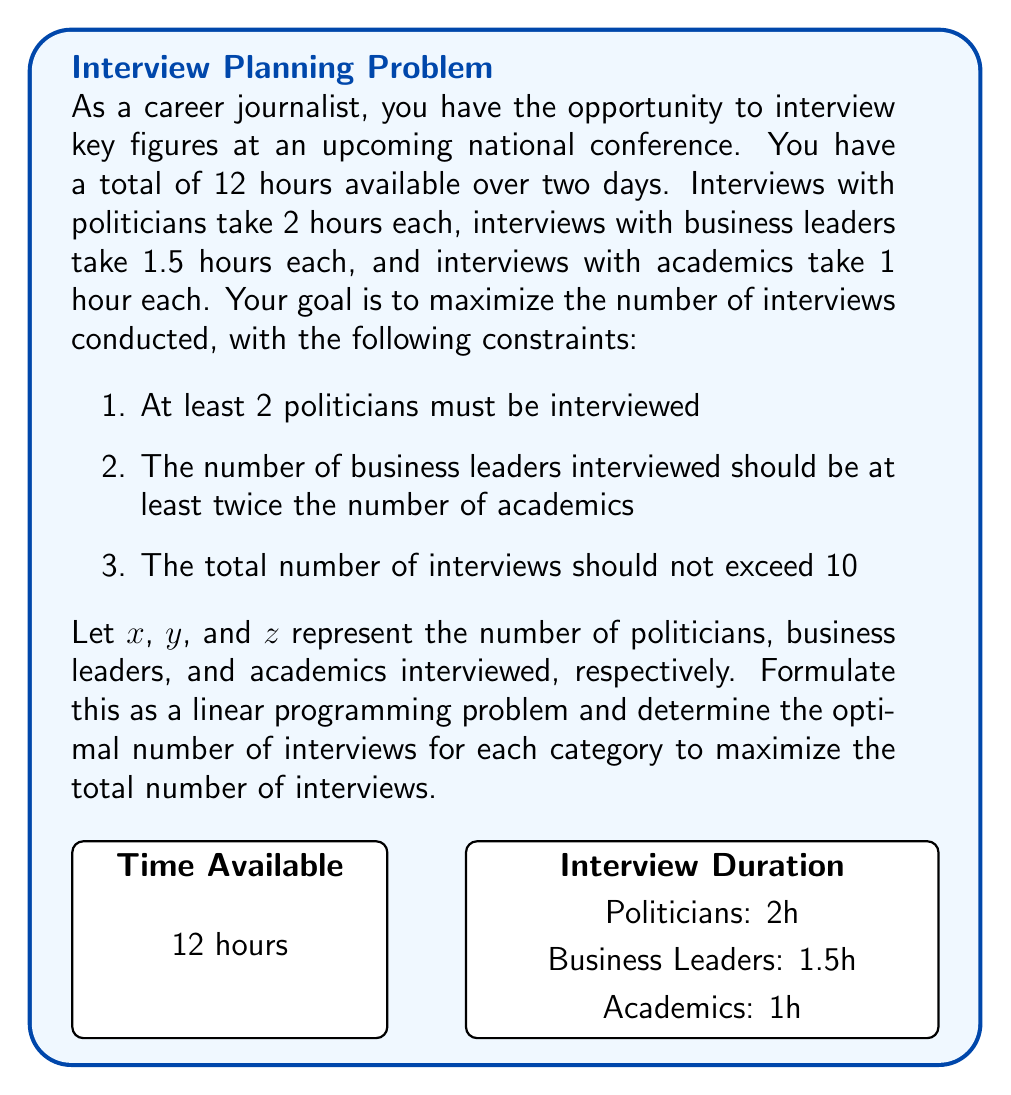Teach me how to tackle this problem. Let's approach this step-by-step:

1) First, we need to formulate the objective function. We want to maximize the total number of interviews:

   Maximize: $Z = x + y + z$

2) Now, let's formulate the constraints:

   a) Time constraint: $2x + 1.5y + z \leq 12$
   b) At least 2 politicians: $x \geq 2$
   c) Business leaders at least twice academics: $y \geq 2z$
   d) Total interviews not exceeding 10: $x + y + z \leq 10$
   e) Non-negativity: $x, y, z \geq 0$

3) This forms our complete linear programming problem:

   Maximize: $Z = x + y + z$
   Subject to:
   $2x + 1.5y + z \leq 12$
   $x \geq 2$
   $y \geq 2z$
   $x + y + z \leq 10$
   $x, y, z \geq 0$ and integers

4) We can solve this using the simplex method or using linear programming software. However, given the integer constraint and the relatively small numbers involved, we can also solve this through logical deduction:

   - We must have at least 2 politicians $(x \geq 2)$
   - To maximize the total, we should use all available time
   - With 2 politicians (4 hours), we have 8 hours left
   - To satisfy $y \geq 2z$ and maximize total interviews, we should have $y = 4$ and $z = 2$

5) This solution $(x=2, y=4, z=2)$ satisfies all constraints:
   - Time: $2(2) + 1.5(4) + 1(2) = 4 + 6 + 2 = 12$ hours
   - At least 2 politicians: $2 \geq 2$
   - Business leaders at least twice academics: $4 \geq 2(2)$
   - Total interviews: $2 + 4 + 2 = 8 \leq 10$

Therefore, the optimal solution is to interview 2 politicians, 4 business leaders, and 2 academics, for a total of 8 interviews.
Answer: 2 politicians, 4 business leaders, 2 academics 